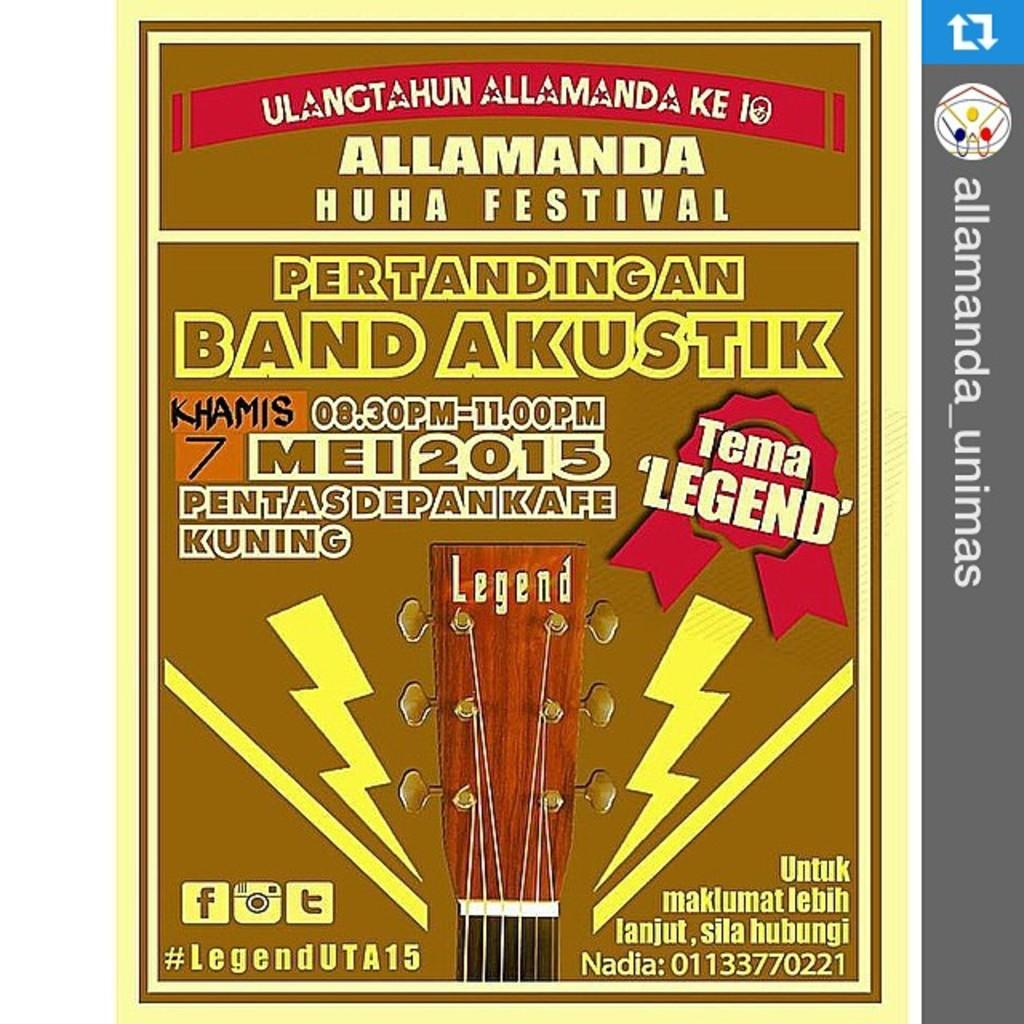<image>
Share a concise interpretation of the image provided. a poster for the allamanda huha festival with a number at the bottom of it 